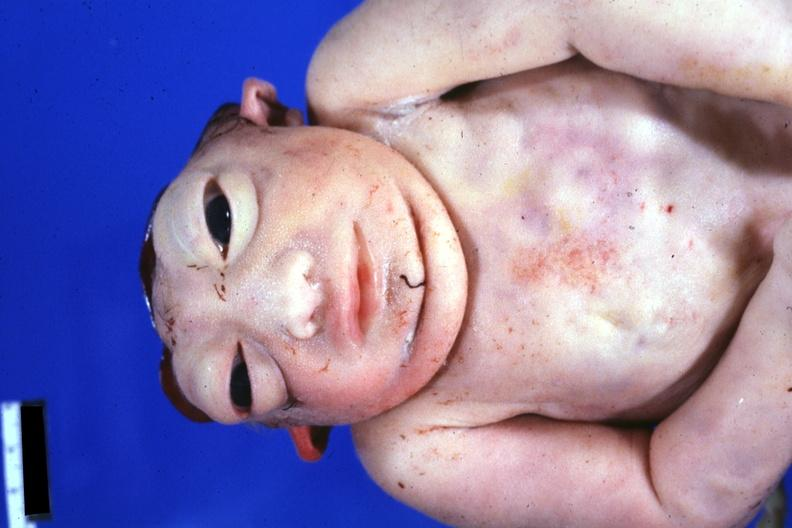does subdiaphragmatic abscess show view of face and chest anterior?
Answer the question using a single word or phrase. No 